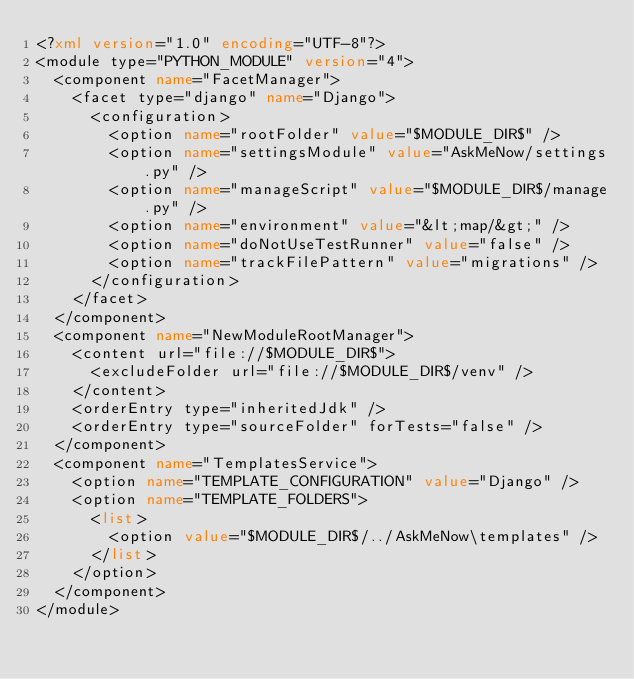<code> <loc_0><loc_0><loc_500><loc_500><_XML_><?xml version="1.0" encoding="UTF-8"?>
<module type="PYTHON_MODULE" version="4">
  <component name="FacetManager">
    <facet type="django" name="Django">
      <configuration>
        <option name="rootFolder" value="$MODULE_DIR$" />
        <option name="settingsModule" value="AskMeNow/settings.py" />
        <option name="manageScript" value="$MODULE_DIR$/manage.py" />
        <option name="environment" value="&lt;map/&gt;" />
        <option name="doNotUseTestRunner" value="false" />
        <option name="trackFilePattern" value="migrations" />
      </configuration>
    </facet>
  </component>
  <component name="NewModuleRootManager">
    <content url="file://$MODULE_DIR$">
      <excludeFolder url="file://$MODULE_DIR$/venv" />
    </content>
    <orderEntry type="inheritedJdk" />
    <orderEntry type="sourceFolder" forTests="false" />
  </component>
  <component name="TemplatesService">
    <option name="TEMPLATE_CONFIGURATION" value="Django" />
    <option name="TEMPLATE_FOLDERS">
      <list>
        <option value="$MODULE_DIR$/../AskMeNow\templates" />
      </list>
    </option>
  </component>
</module></code> 